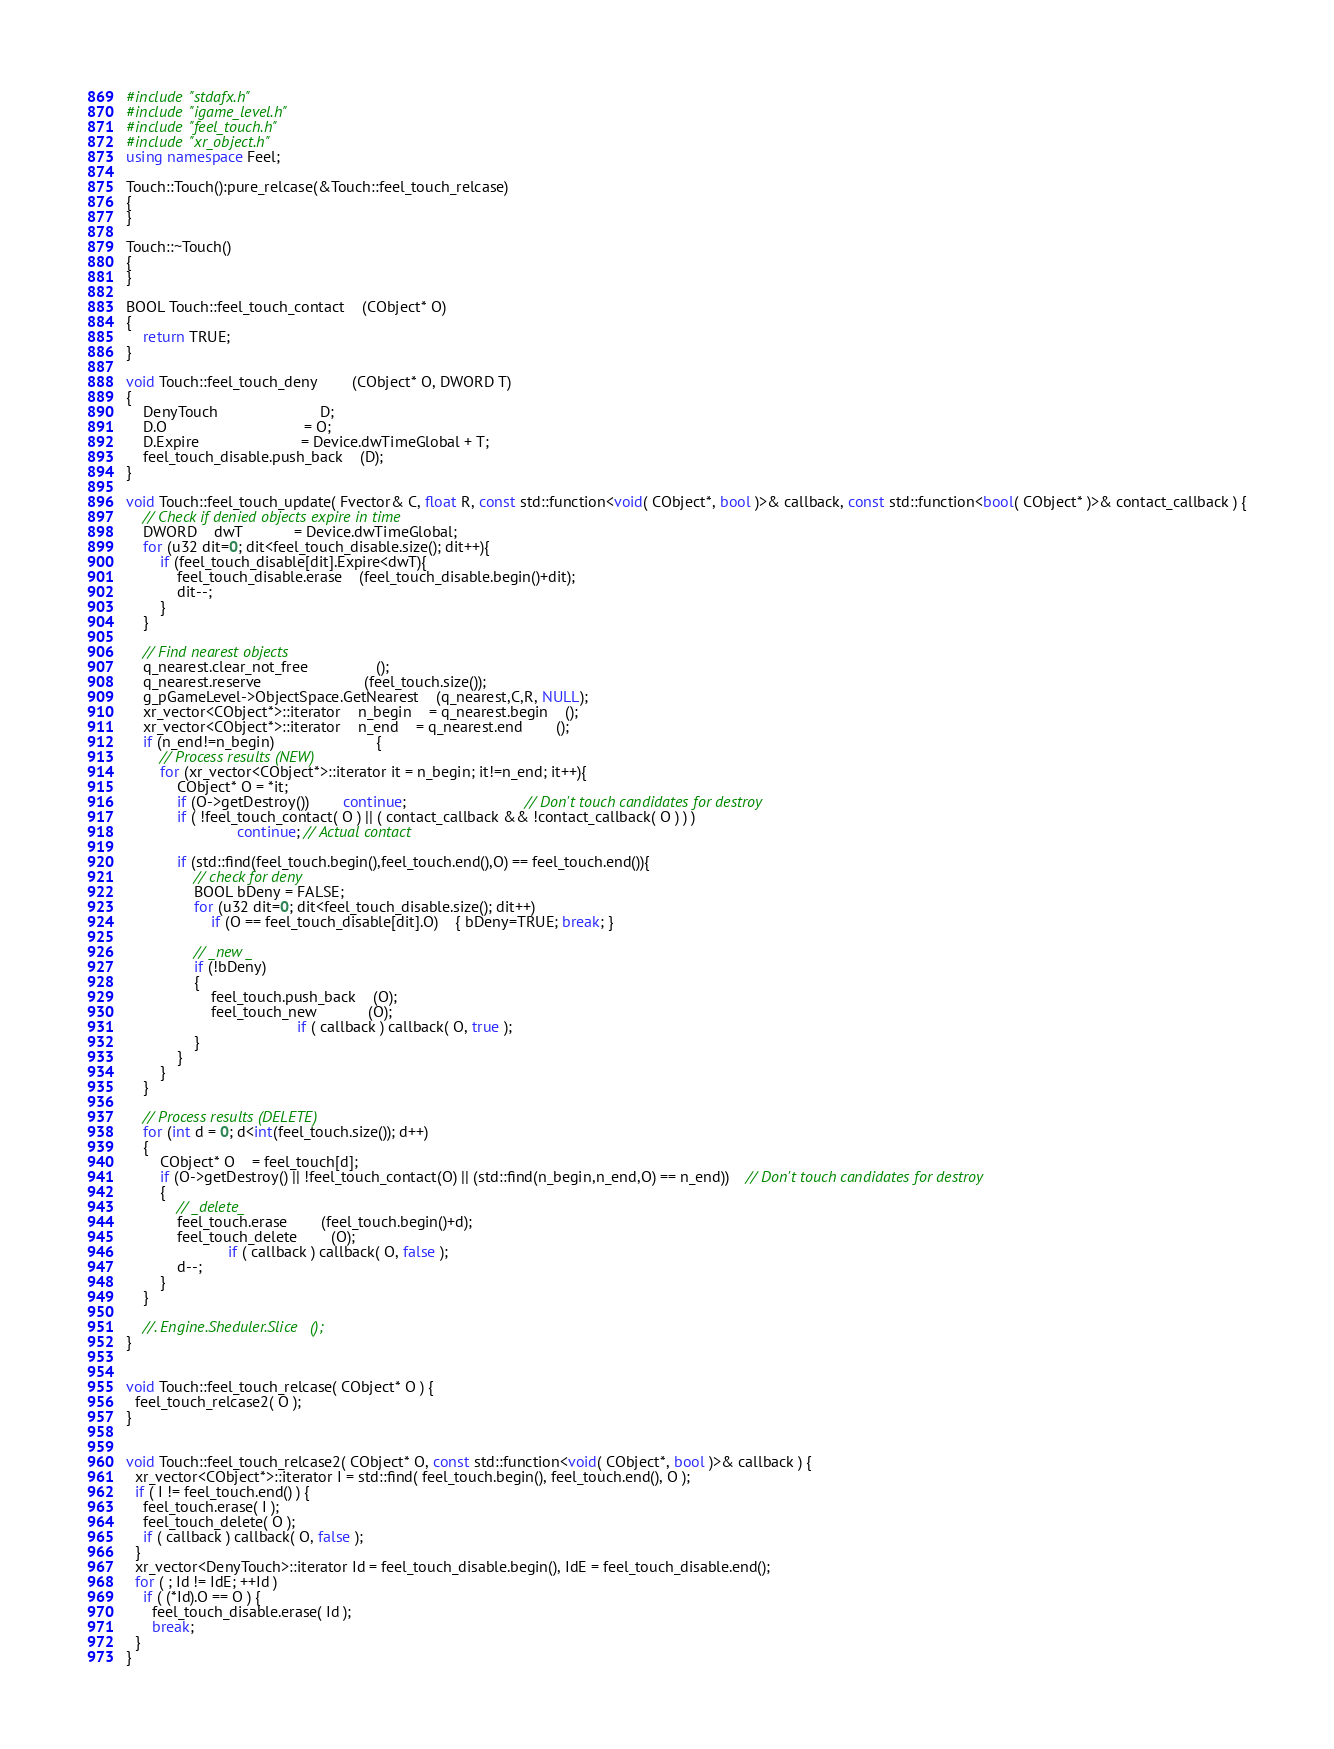<code> <loc_0><loc_0><loc_500><loc_500><_C++_>#include "stdafx.h"
#include "igame_level.h"
#include "feel_touch.h"
#include "xr_object.h"
using namespace Feel;

Touch::Touch():pure_relcase(&Touch::feel_touch_relcase)
{
}

Touch::~Touch()
{
}

BOOL Touch::feel_touch_contact	(CObject* O)
{ 
	return TRUE; 
}

void Touch::feel_touch_deny		(CObject* O, DWORD T)
{
	DenyTouch						D;
	D.O								= O;
	D.Expire						= Device.dwTimeGlobal + T;
	feel_touch_disable.push_back	(D);
}

void Touch::feel_touch_update( Fvector& C, float R, const std::function<void( CObject*, bool )>& callback, const std::function<bool( CObject* )>& contact_callback ) {
	// Check if denied objects expire in time
	DWORD	dwT			= Device.dwTimeGlobal;
	for (u32 dit=0; dit<feel_touch_disable.size(); dit++){
		if (feel_touch_disable[dit].Expire<dwT){
			feel_touch_disable.erase	(feel_touch_disable.begin()+dit);
			dit--;
		}
	}

	// Find nearest objects
	q_nearest.clear_not_free				();
	q_nearest.reserve						(feel_touch.size());
	g_pGameLevel->ObjectSpace.GetNearest	(q_nearest,C,R, NULL);
	xr_vector<CObject*>::iterator	n_begin	= q_nearest.begin	();
	xr_vector<CObject*>::iterator	n_end	= q_nearest.end		();
	if (n_end!=n_begin)						{
		// Process results (NEW)
		for (xr_vector<CObject*>::iterator it = n_begin; it!=n_end; it++){
			CObject* O = *it;
			if (O->getDestroy())		continue;							// Don't touch candidates for destroy
			if ( !feel_touch_contact( O ) || ( contact_callback && !contact_callback( O ) ) )
                          continue; // Actual contact

			if (std::find(feel_touch.begin(),feel_touch.end(),O) == feel_touch.end()){
				// check for deny
				BOOL bDeny = FALSE;
				for (u32 dit=0; dit<feel_touch_disable.size(); dit++)
					if (O == feel_touch_disable[dit].O)	{ bDeny=TRUE; break; }

				// _new _
				if (!bDeny)
				{
					feel_touch.push_back	(O);
					feel_touch_new			(O);
                                        if ( callback ) callback( O, true );
				}
			}
		}
	}

	// Process results (DELETE)
	for (int d = 0; d<int(feel_touch.size()); d++)
	{
		CObject* O	= feel_touch[d];
		if (O->getDestroy() || !feel_touch_contact(O) || (std::find(n_begin,n_end,O) == n_end))	// Don't touch candidates for destroy
		{
			// _delete_
			feel_touch.erase		(feel_touch.begin()+d);
			feel_touch_delete		(O);
                        if ( callback ) callback( O, false );
			d--;
		}
	}

	//. Engine.Sheduler.Slice	();	
}


void Touch::feel_touch_relcase( CObject* O ) {
  feel_touch_relcase2( O );
}


void Touch::feel_touch_relcase2( CObject* O, const std::function<void( CObject*, bool )>& callback ) {
  xr_vector<CObject*>::iterator I = std::find( feel_touch.begin(), feel_touch.end(), O );
  if ( I != feel_touch.end() ) {
    feel_touch.erase( I );
    feel_touch_delete( O );
    if ( callback ) callback( O, false );
  }
  xr_vector<DenyTouch>::iterator Id = feel_touch_disable.begin(), IdE = feel_touch_disable.end();
  for ( ; Id != IdE; ++Id )
    if ( (*Id).O == O ) {
      feel_touch_disable.erase( Id );
      break;
  }
}
</code> 